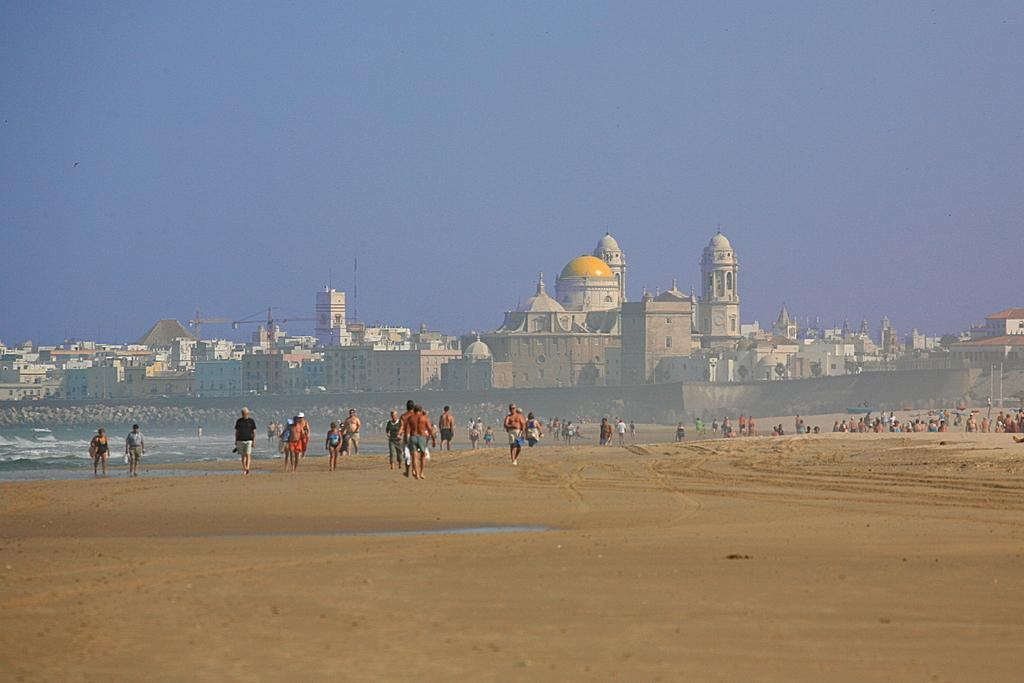What type of structures can be seen in the image? There are buildings in the image. Who or what else is present in the image? There are people in the image. What natural element is visible in the image? There is water visible in the image. What can be seen in the background of the image? The sky and a wall are visible in the background of the image. What type of wire is being used to hold the print in the image? There is no wire or print present in the image. 